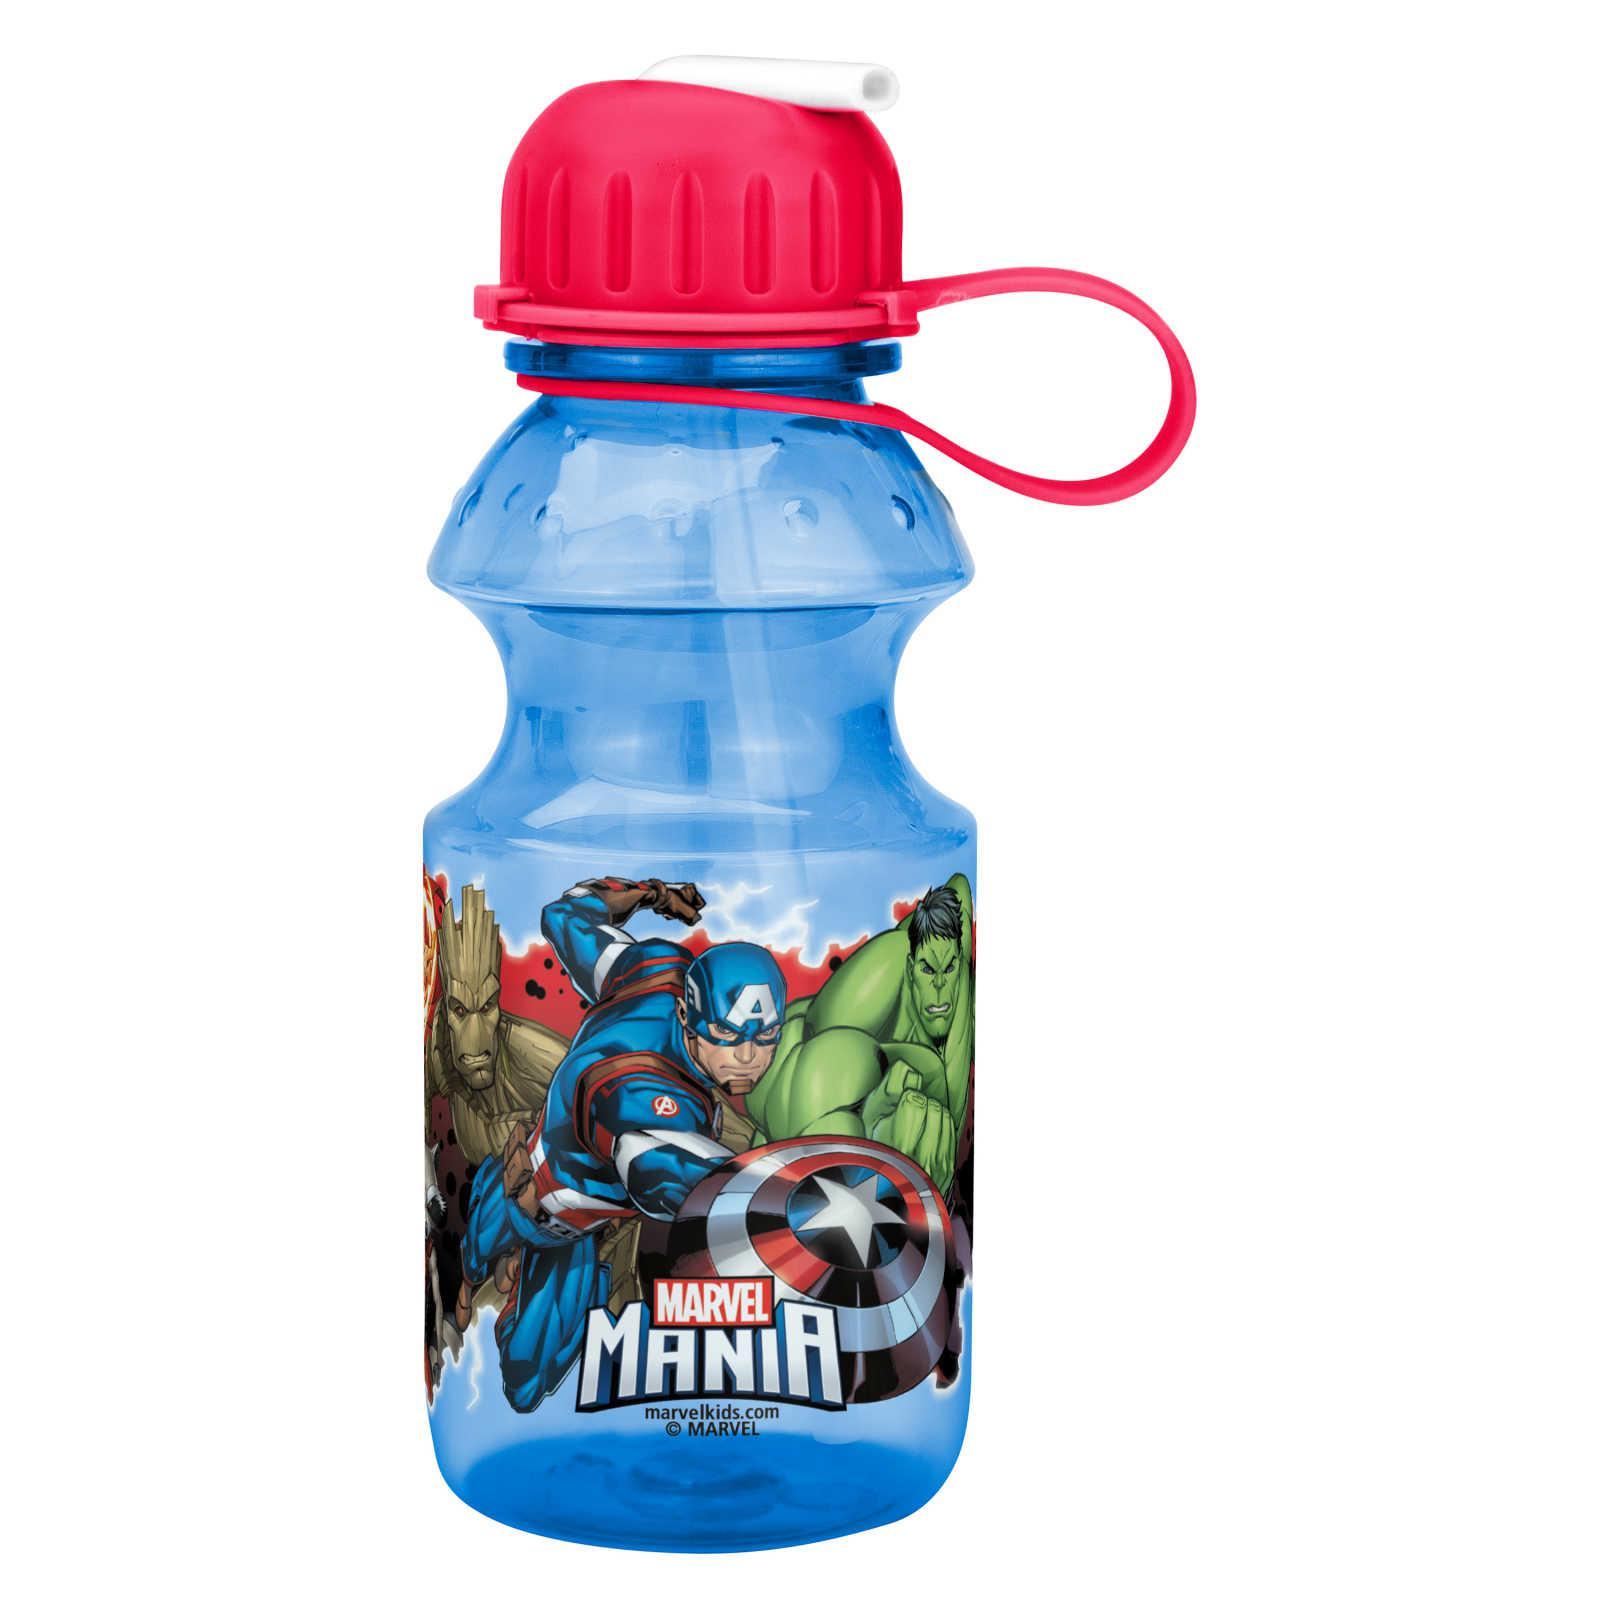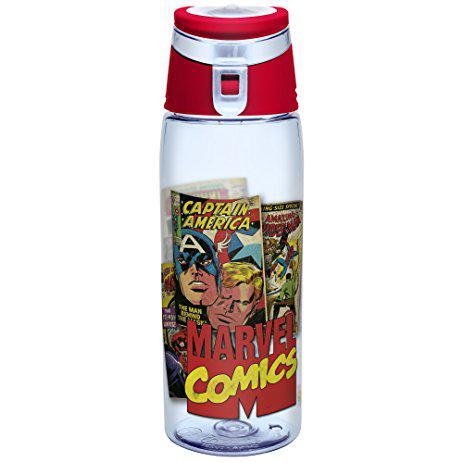The first image is the image on the left, the second image is the image on the right. For the images displayed, is the sentence "There is a bottle with a red lid." factually correct? Answer yes or no. Yes. The first image is the image on the left, the second image is the image on the right. Analyze the images presented: Is the assertion "Each water bottle has a black lid, and one water bottle has a grid of at least six square super hero pictures on its front." valid? Answer yes or no. No. 